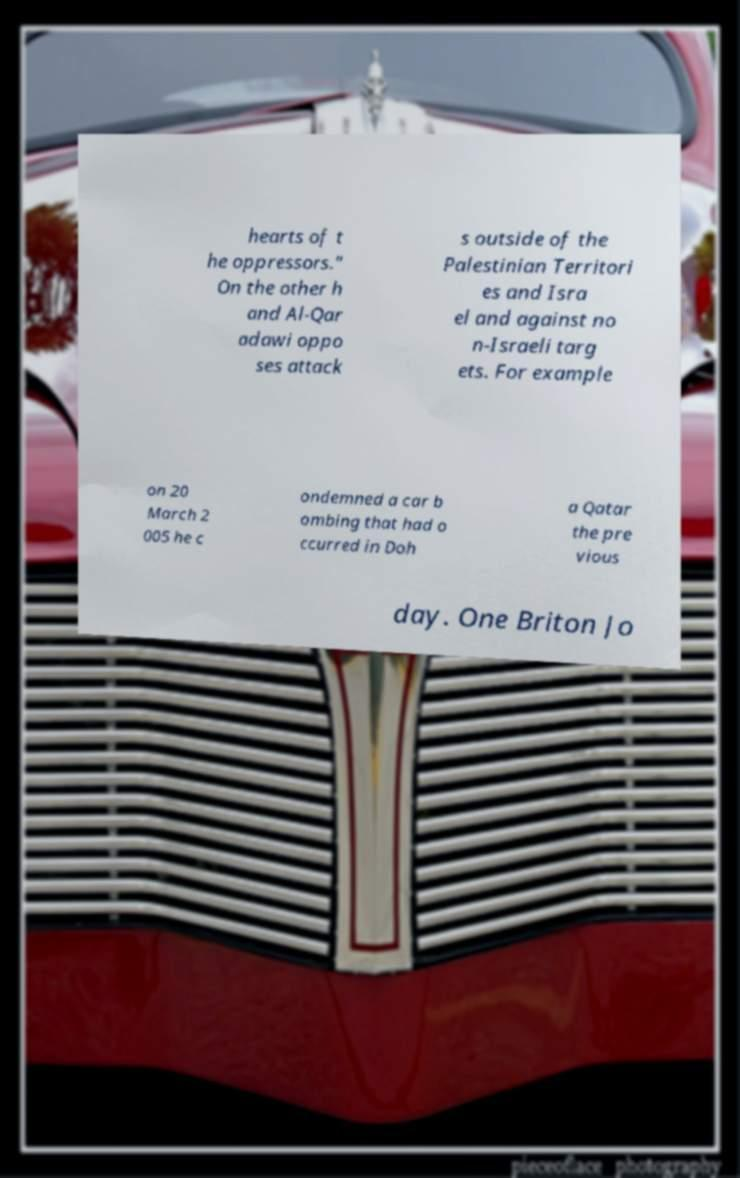Could you assist in decoding the text presented in this image and type it out clearly? hearts of t he oppressors." On the other h and Al-Qar adawi oppo ses attack s outside of the Palestinian Territori es and Isra el and against no n-Israeli targ ets. For example on 20 March 2 005 he c ondemned a car b ombing that had o ccurred in Doh a Qatar the pre vious day. One Briton Jo 